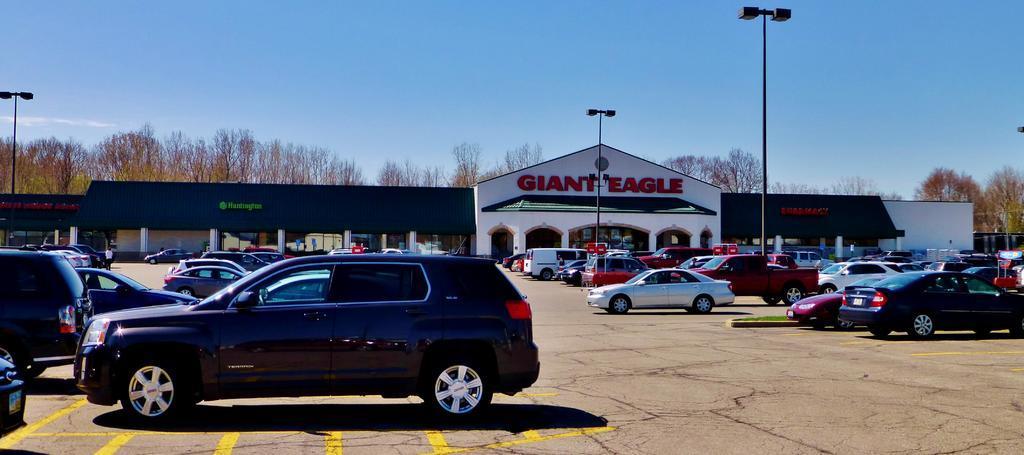Could you give a brief overview of what you see in this image? In this image we can see a few vehicles parked on the ground, there are light poles and buildings with text and in the background there are trees and the sky. 